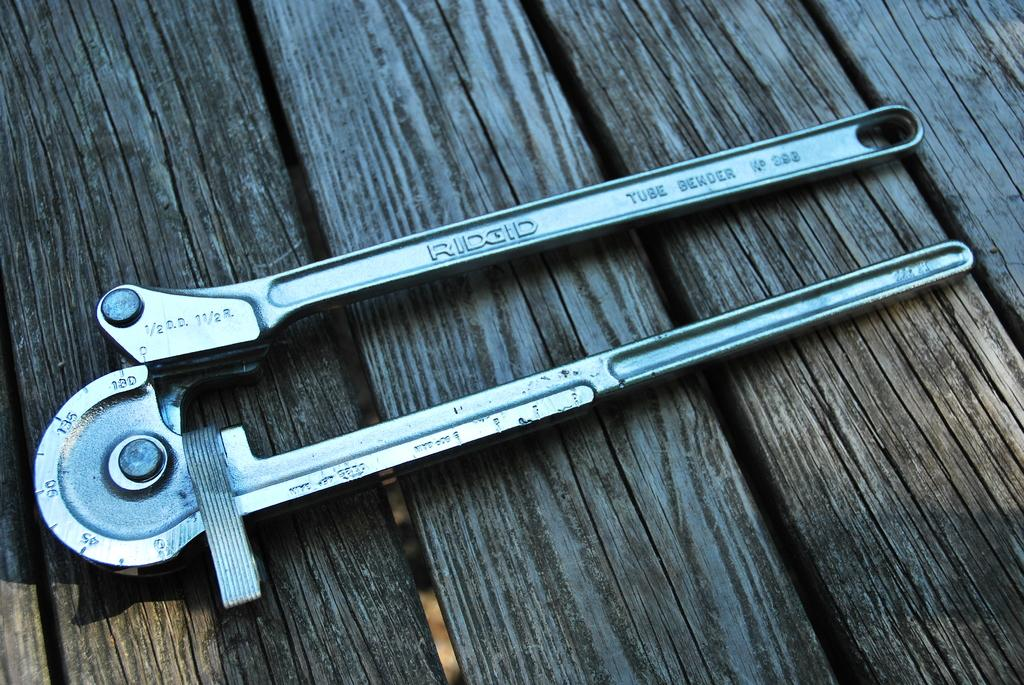What object is the main subject of the image? There is a cutter in the image. Where is the cutter located? The cutter is on a wooden table. What type of fear can be seen on the donkey's face in the image? There is no donkey present in the image, so it is not possible to determine any fear on its face. 